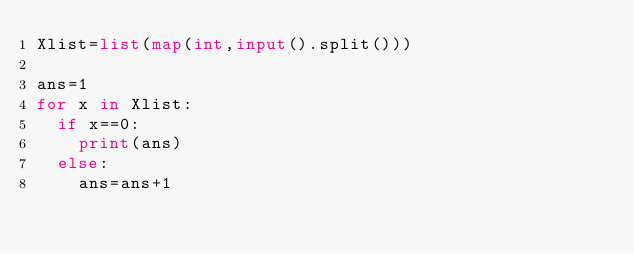<code> <loc_0><loc_0><loc_500><loc_500><_Python_>Xlist=list(map(int,input().split()))

ans=1 
for x in Xlist:
	if x==0:
		print(ans)
	else:
		ans=ans+1
</code> 